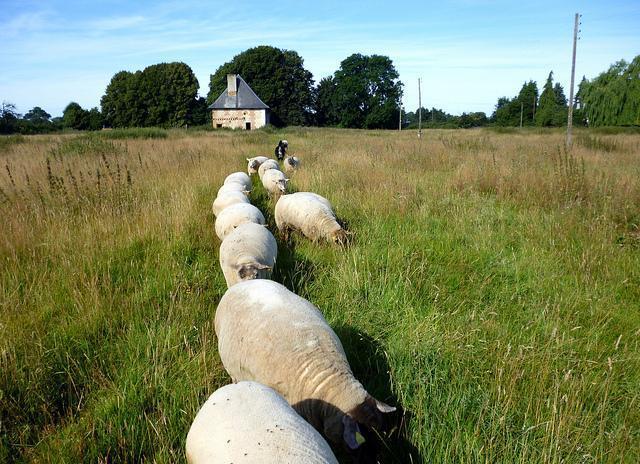How many buildings are in the background?
Give a very brief answer. 1. How many sheep can be seen?
Give a very brief answer. 4. 